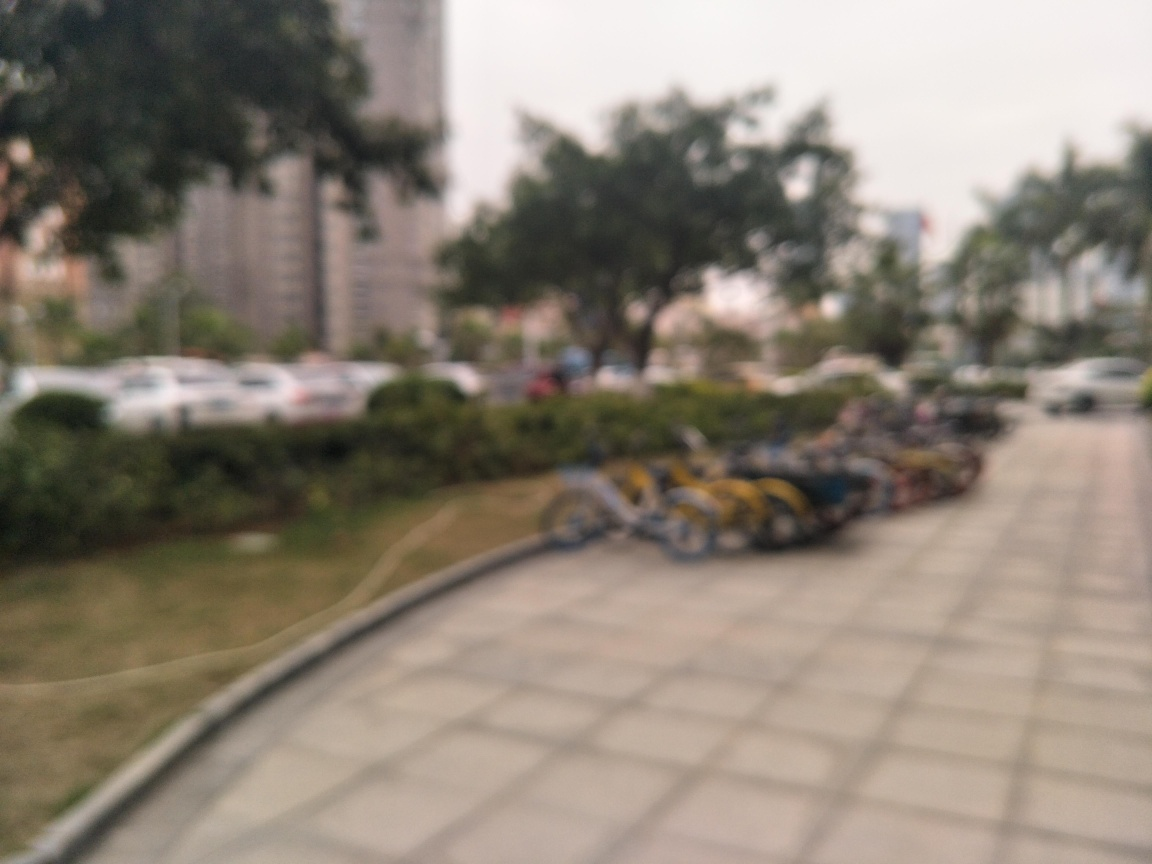What time of day does this scene depict? It's challenging to determine the exact time due to the blur, but the lighting suggests it could be late afternoon or early evening, judging by the softness and warmth of the light. 